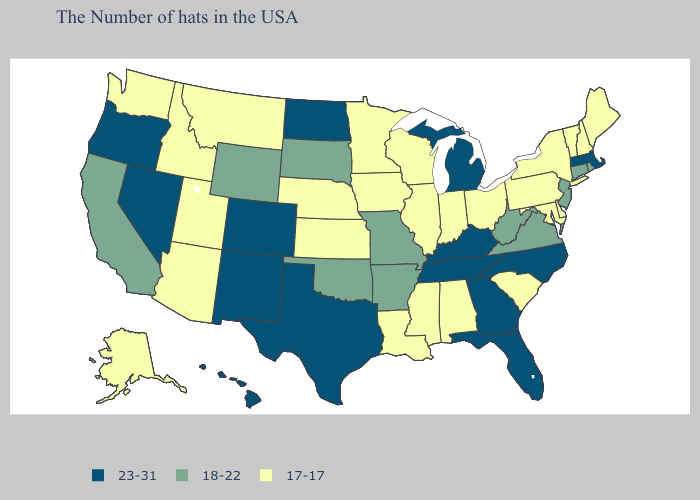What is the value of Colorado?
Be succinct. 23-31. What is the highest value in states that border Mississippi?
Quick response, please. 23-31. What is the value of South Carolina?
Give a very brief answer. 17-17. Among the states that border Maryland , does West Virginia have the highest value?
Keep it brief. Yes. Name the states that have a value in the range 17-17?
Short answer required. Maine, New Hampshire, Vermont, New York, Delaware, Maryland, Pennsylvania, South Carolina, Ohio, Indiana, Alabama, Wisconsin, Illinois, Mississippi, Louisiana, Minnesota, Iowa, Kansas, Nebraska, Utah, Montana, Arizona, Idaho, Washington, Alaska. Among the states that border Kentucky , does Indiana have the lowest value?
Give a very brief answer. Yes. What is the value of Kentucky?
Give a very brief answer. 23-31. Does Hawaii have the same value as Mississippi?
Short answer required. No. What is the value of Minnesota?
Answer briefly. 17-17. Does Wyoming have a lower value than Oklahoma?
Give a very brief answer. No. What is the lowest value in the South?
Write a very short answer. 17-17. How many symbols are there in the legend?
Answer briefly. 3. Name the states that have a value in the range 18-22?
Write a very short answer. Rhode Island, Connecticut, New Jersey, Virginia, West Virginia, Missouri, Arkansas, Oklahoma, South Dakota, Wyoming, California. Name the states that have a value in the range 18-22?
Quick response, please. Rhode Island, Connecticut, New Jersey, Virginia, West Virginia, Missouri, Arkansas, Oklahoma, South Dakota, Wyoming, California. 